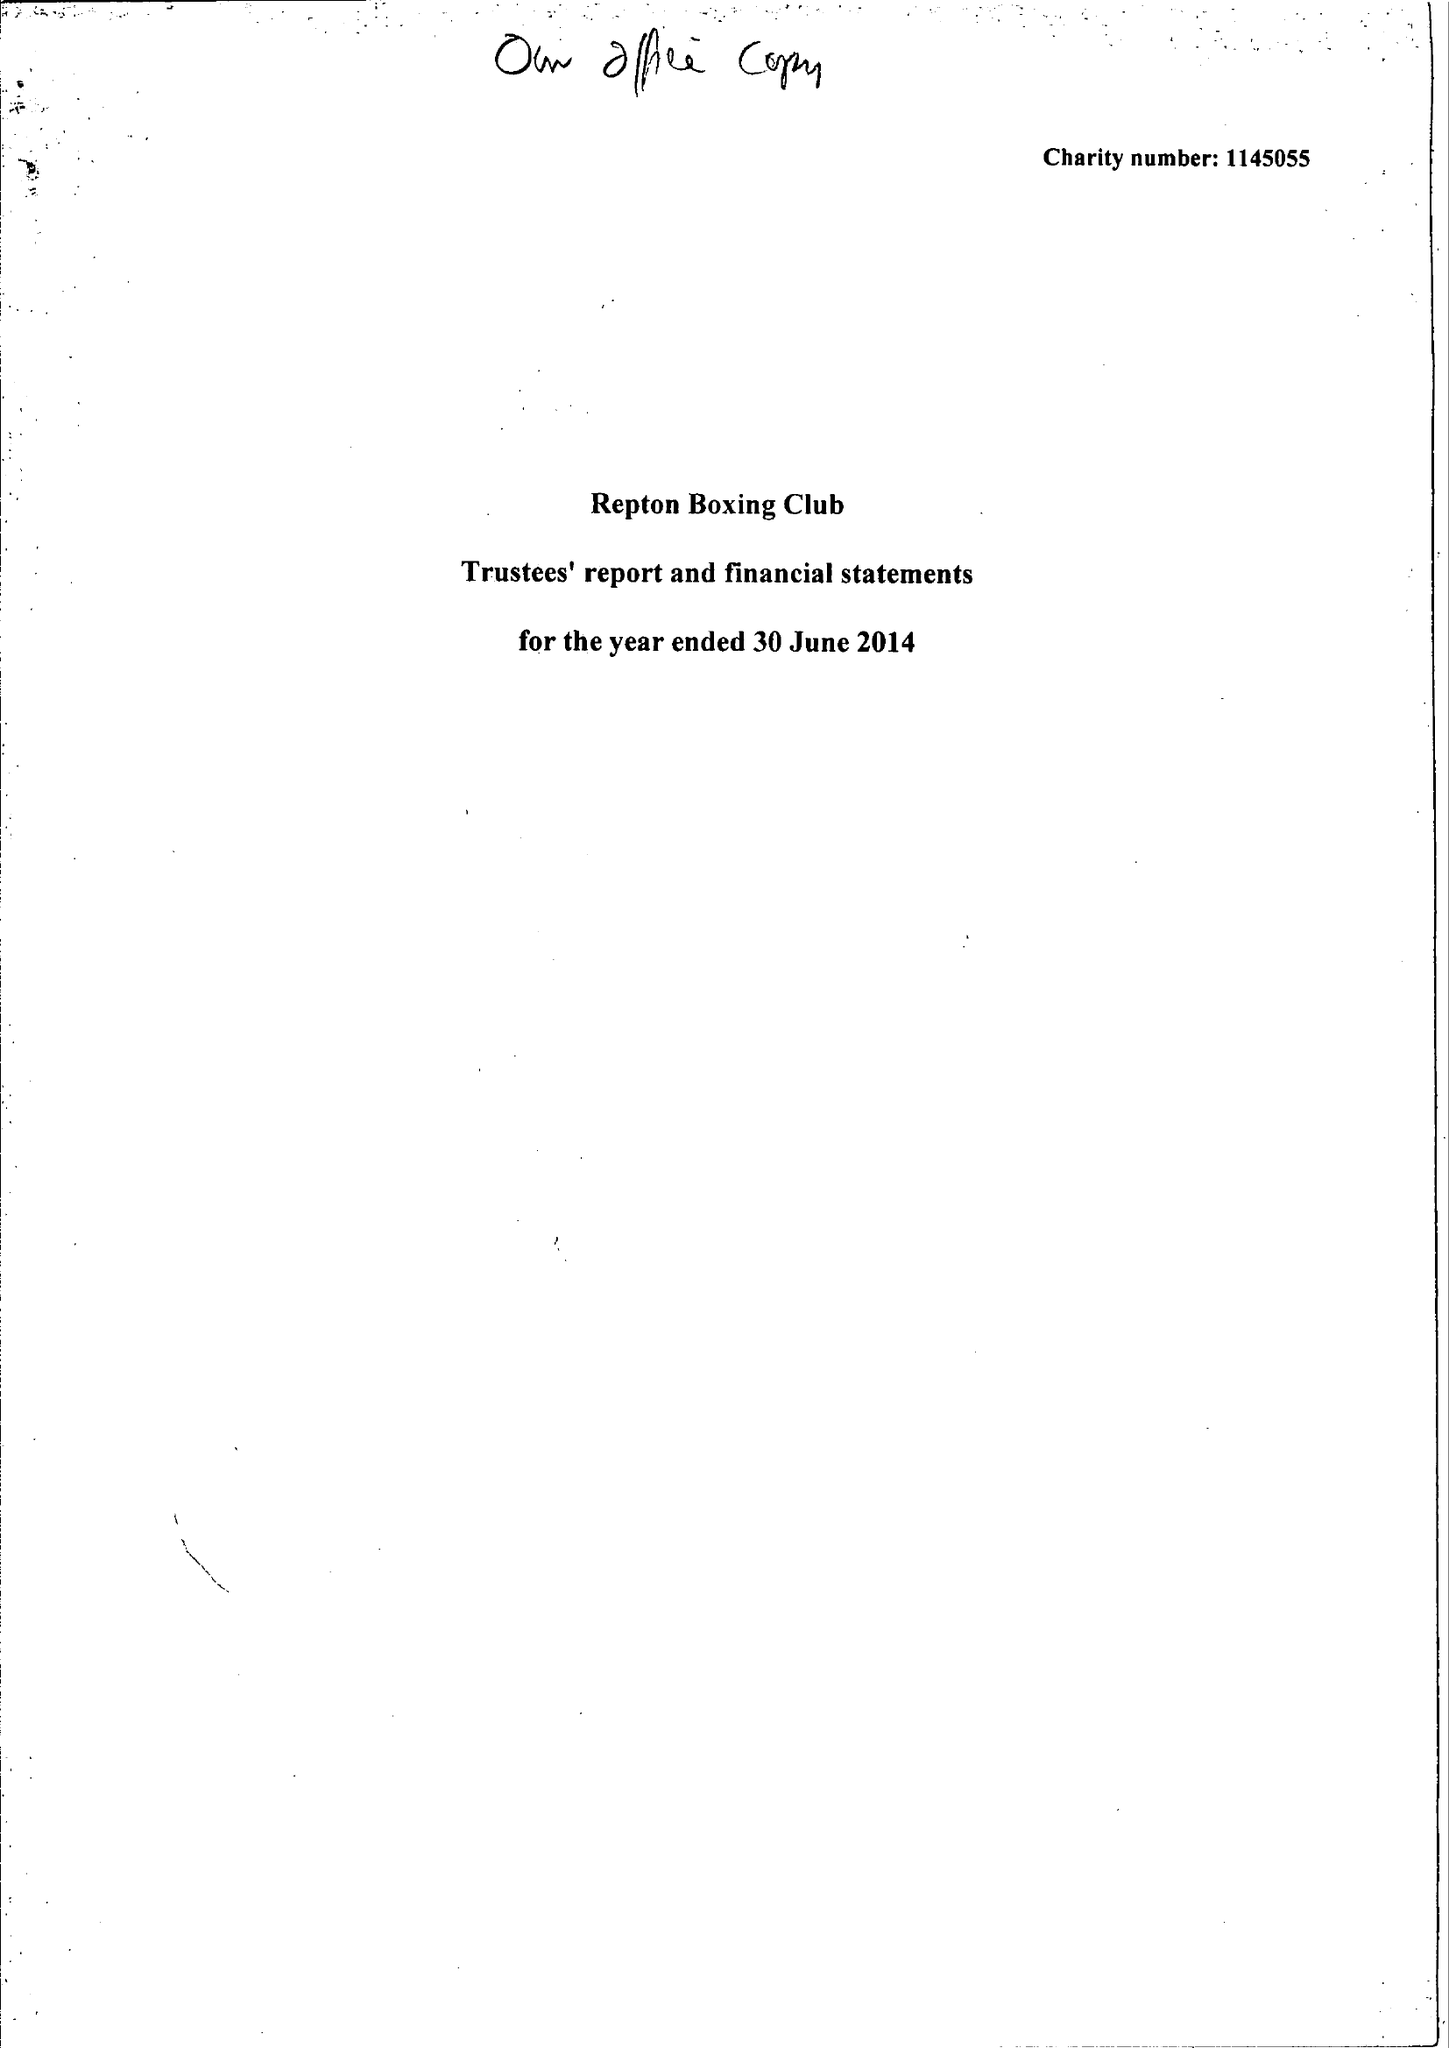What is the value for the charity_name?
Answer the question using a single word or phrase. Repton Boxing Club 